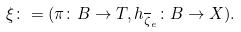Convert formula to latex. <formula><loc_0><loc_0><loc_500><loc_500>\xi \colon = ( \pi \colon B \rightarrow T , h _ { \overline { \zeta } _ { e } } \colon B \rightarrow X ) .</formula> 